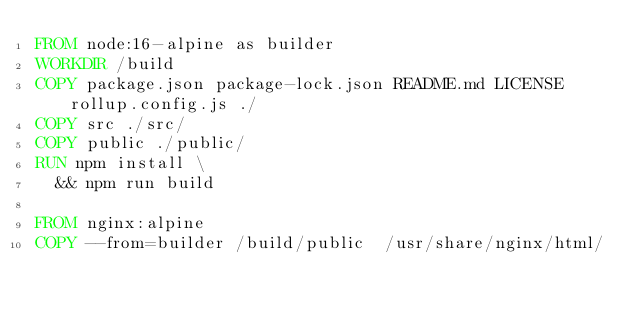<code> <loc_0><loc_0><loc_500><loc_500><_Dockerfile_>FROM node:16-alpine as builder
WORKDIR /build
COPY package.json package-lock.json README.md LICENSE rollup.config.js ./
COPY src ./src/
COPY public ./public/
RUN npm install \
  && npm run build

FROM nginx:alpine
COPY --from=builder /build/public  /usr/share/nginx/html/</code> 